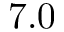<formula> <loc_0><loc_0><loc_500><loc_500>7 . 0</formula> 